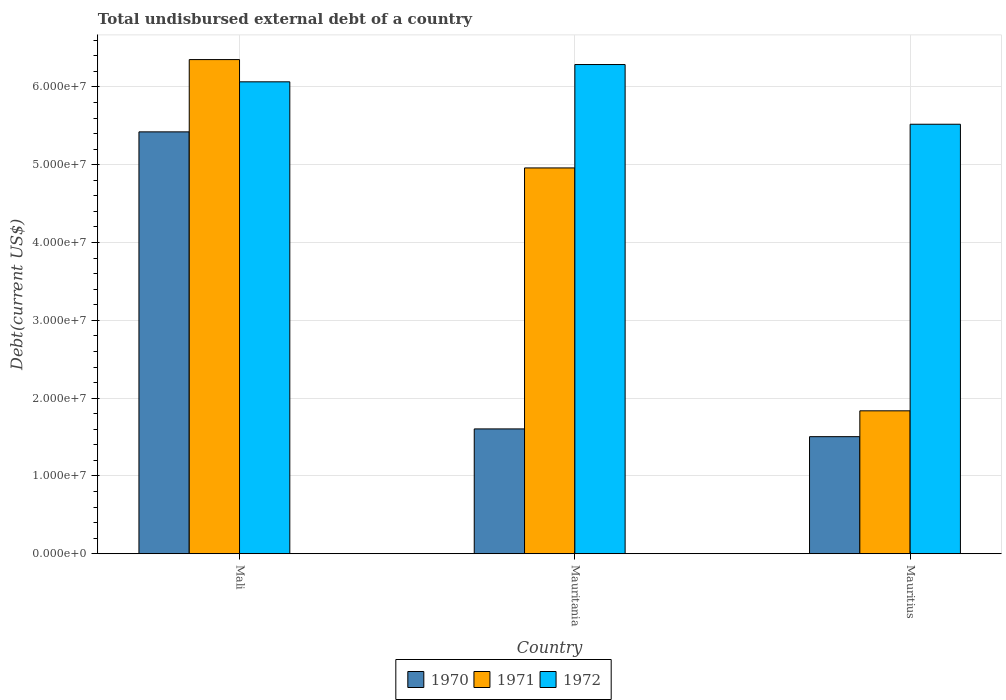Are the number of bars on each tick of the X-axis equal?
Your response must be concise. Yes. How many bars are there on the 3rd tick from the left?
Offer a terse response. 3. How many bars are there on the 2nd tick from the right?
Give a very brief answer. 3. What is the label of the 3rd group of bars from the left?
Provide a succinct answer. Mauritius. What is the total undisbursed external debt in 1972 in Mauritania?
Offer a very short reply. 6.29e+07. Across all countries, what is the maximum total undisbursed external debt in 1972?
Keep it short and to the point. 6.29e+07. Across all countries, what is the minimum total undisbursed external debt in 1972?
Provide a short and direct response. 5.52e+07. In which country was the total undisbursed external debt in 1972 maximum?
Keep it short and to the point. Mauritania. In which country was the total undisbursed external debt in 1970 minimum?
Offer a very short reply. Mauritius. What is the total total undisbursed external debt in 1971 in the graph?
Give a very brief answer. 1.31e+08. What is the difference between the total undisbursed external debt in 1971 in Mauritania and that in Mauritius?
Provide a succinct answer. 3.12e+07. What is the difference between the total undisbursed external debt in 1970 in Mauritania and the total undisbursed external debt in 1971 in Mauritius?
Offer a terse response. -2.33e+06. What is the average total undisbursed external debt in 1972 per country?
Your response must be concise. 5.96e+07. What is the difference between the total undisbursed external debt of/in 1972 and total undisbursed external debt of/in 1970 in Mauritania?
Keep it short and to the point. 4.68e+07. In how many countries, is the total undisbursed external debt in 1972 greater than 40000000 US$?
Ensure brevity in your answer.  3. What is the ratio of the total undisbursed external debt in 1970 in Mali to that in Mauritania?
Your answer should be compact. 3.38. Is the total undisbursed external debt in 1972 in Mauritania less than that in Mauritius?
Offer a very short reply. No. Is the difference between the total undisbursed external debt in 1972 in Mali and Mauritania greater than the difference between the total undisbursed external debt in 1970 in Mali and Mauritania?
Ensure brevity in your answer.  No. What is the difference between the highest and the second highest total undisbursed external debt in 1971?
Provide a short and direct response. 4.51e+07. What is the difference between the highest and the lowest total undisbursed external debt in 1972?
Ensure brevity in your answer.  7.67e+06. Is the sum of the total undisbursed external debt in 1970 in Mali and Mauritius greater than the maximum total undisbursed external debt in 1971 across all countries?
Your answer should be compact. Yes. What does the 3rd bar from the left in Mali represents?
Your response must be concise. 1972. How many countries are there in the graph?
Your answer should be compact. 3. What is the difference between two consecutive major ticks on the Y-axis?
Make the answer very short. 1.00e+07. Does the graph contain grids?
Provide a short and direct response. Yes. Where does the legend appear in the graph?
Provide a succinct answer. Bottom center. What is the title of the graph?
Keep it short and to the point. Total undisbursed external debt of a country. What is the label or title of the Y-axis?
Your response must be concise. Debt(current US$). What is the Debt(current US$) in 1970 in Mali?
Ensure brevity in your answer.  5.42e+07. What is the Debt(current US$) in 1971 in Mali?
Provide a short and direct response. 6.35e+07. What is the Debt(current US$) of 1972 in Mali?
Offer a very short reply. 6.07e+07. What is the Debt(current US$) in 1970 in Mauritania?
Offer a terse response. 1.60e+07. What is the Debt(current US$) in 1971 in Mauritania?
Ensure brevity in your answer.  4.96e+07. What is the Debt(current US$) of 1972 in Mauritania?
Your answer should be compact. 6.29e+07. What is the Debt(current US$) in 1970 in Mauritius?
Give a very brief answer. 1.50e+07. What is the Debt(current US$) in 1971 in Mauritius?
Provide a succinct answer. 1.84e+07. What is the Debt(current US$) of 1972 in Mauritius?
Your answer should be very brief. 5.52e+07. Across all countries, what is the maximum Debt(current US$) of 1970?
Offer a terse response. 5.42e+07. Across all countries, what is the maximum Debt(current US$) in 1971?
Give a very brief answer. 6.35e+07. Across all countries, what is the maximum Debt(current US$) in 1972?
Your response must be concise. 6.29e+07. Across all countries, what is the minimum Debt(current US$) of 1970?
Your answer should be compact. 1.50e+07. Across all countries, what is the minimum Debt(current US$) in 1971?
Make the answer very short. 1.84e+07. Across all countries, what is the minimum Debt(current US$) in 1972?
Keep it short and to the point. 5.52e+07. What is the total Debt(current US$) in 1970 in the graph?
Offer a very short reply. 8.53e+07. What is the total Debt(current US$) of 1971 in the graph?
Your response must be concise. 1.31e+08. What is the total Debt(current US$) of 1972 in the graph?
Ensure brevity in your answer.  1.79e+08. What is the difference between the Debt(current US$) in 1970 in Mali and that in Mauritania?
Your response must be concise. 3.82e+07. What is the difference between the Debt(current US$) of 1971 in Mali and that in Mauritania?
Your answer should be very brief. 1.39e+07. What is the difference between the Debt(current US$) in 1972 in Mali and that in Mauritania?
Provide a short and direct response. -2.22e+06. What is the difference between the Debt(current US$) of 1970 in Mali and that in Mauritius?
Your answer should be very brief. 3.92e+07. What is the difference between the Debt(current US$) of 1971 in Mali and that in Mauritius?
Ensure brevity in your answer.  4.51e+07. What is the difference between the Debt(current US$) in 1972 in Mali and that in Mauritius?
Give a very brief answer. 5.45e+06. What is the difference between the Debt(current US$) in 1970 in Mauritania and that in Mauritius?
Make the answer very short. 9.95e+05. What is the difference between the Debt(current US$) in 1971 in Mauritania and that in Mauritius?
Make the answer very short. 3.12e+07. What is the difference between the Debt(current US$) in 1972 in Mauritania and that in Mauritius?
Provide a succinct answer. 7.67e+06. What is the difference between the Debt(current US$) in 1970 in Mali and the Debt(current US$) in 1971 in Mauritania?
Keep it short and to the point. 4.64e+06. What is the difference between the Debt(current US$) of 1970 in Mali and the Debt(current US$) of 1972 in Mauritania?
Offer a very short reply. -8.65e+06. What is the difference between the Debt(current US$) in 1971 in Mali and the Debt(current US$) in 1972 in Mauritania?
Offer a terse response. 6.38e+05. What is the difference between the Debt(current US$) of 1970 in Mali and the Debt(current US$) of 1971 in Mauritius?
Ensure brevity in your answer.  3.59e+07. What is the difference between the Debt(current US$) of 1970 in Mali and the Debt(current US$) of 1972 in Mauritius?
Offer a terse response. -9.81e+05. What is the difference between the Debt(current US$) in 1971 in Mali and the Debt(current US$) in 1972 in Mauritius?
Offer a very short reply. 8.31e+06. What is the difference between the Debt(current US$) in 1970 in Mauritania and the Debt(current US$) in 1971 in Mauritius?
Give a very brief answer. -2.33e+06. What is the difference between the Debt(current US$) of 1970 in Mauritania and the Debt(current US$) of 1972 in Mauritius?
Make the answer very short. -3.92e+07. What is the difference between the Debt(current US$) in 1971 in Mauritania and the Debt(current US$) in 1972 in Mauritius?
Keep it short and to the point. -5.62e+06. What is the average Debt(current US$) in 1970 per country?
Offer a terse response. 2.84e+07. What is the average Debt(current US$) of 1971 per country?
Provide a short and direct response. 4.38e+07. What is the average Debt(current US$) in 1972 per country?
Offer a very short reply. 5.96e+07. What is the difference between the Debt(current US$) in 1970 and Debt(current US$) in 1971 in Mali?
Your answer should be compact. -9.29e+06. What is the difference between the Debt(current US$) of 1970 and Debt(current US$) of 1972 in Mali?
Ensure brevity in your answer.  -6.43e+06. What is the difference between the Debt(current US$) of 1971 and Debt(current US$) of 1972 in Mali?
Offer a terse response. 2.86e+06. What is the difference between the Debt(current US$) of 1970 and Debt(current US$) of 1971 in Mauritania?
Offer a very short reply. -3.35e+07. What is the difference between the Debt(current US$) of 1970 and Debt(current US$) of 1972 in Mauritania?
Provide a succinct answer. -4.68e+07. What is the difference between the Debt(current US$) in 1971 and Debt(current US$) in 1972 in Mauritania?
Your answer should be compact. -1.33e+07. What is the difference between the Debt(current US$) in 1970 and Debt(current US$) in 1971 in Mauritius?
Your answer should be compact. -3.32e+06. What is the difference between the Debt(current US$) in 1970 and Debt(current US$) in 1972 in Mauritius?
Provide a succinct answer. -4.02e+07. What is the difference between the Debt(current US$) of 1971 and Debt(current US$) of 1972 in Mauritius?
Ensure brevity in your answer.  -3.68e+07. What is the ratio of the Debt(current US$) of 1970 in Mali to that in Mauritania?
Provide a succinct answer. 3.38. What is the ratio of the Debt(current US$) in 1971 in Mali to that in Mauritania?
Provide a succinct answer. 1.28. What is the ratio of the Debt(current US$) in 1972 in Mali to that in Mauritania?
Your response must be concise. 0.96. What is the ratio of the Debt(current US$) in 1970 in Mali to that in Mauritius?
Provide a short and direct response. 3.6. What is the ratio of the Debt(current US$) of 1971 in Mali to that in Mauritius?
Offer a very short reply. 3.46. What is the ratio of the Debt(current US$) in 1972 in Mali to that in Mauritius?
Offer a terse response. 1.1. What is the ratio of the Debt(current US$) in 1970 in Mauritania to that in Mauritius?
Give a very brief answer. 1.07. What is the ratio of the Debt(current US$) in 1971 in Mauritania to that in Mauritius?
Provide a succinct answer. 2.7. What is the ratio of the Debt(current US$) in 1972 in Mauritania to that in Mauritius?
Offer a terse response. 1.14. What is the difference between the highest and the second highest Debt(current US$) of 1970?
Your answer should be compact. 3.82e+07. What is the difference between the highest and the second highest Debt(current US$) of 1971?
Provide a short and direct response. 1.39e+07. What is the difference between the highest and the second highest Debt(current US$) in 1972?
Offer a very short reply. 2.22e+06. What is the difference between the highest and the lowest Debt(current US$) in 1970?
Ensure brevity in your answer.  3.92e+07. What is the difference between the highest and the lowest Debt(current US$) in 1971?
Offer a very short reply. 4.51e+07. What is the difference between the highest and the lowest Debt(current US$) of 1972?
Your response must be concise. 7.67e+06. 